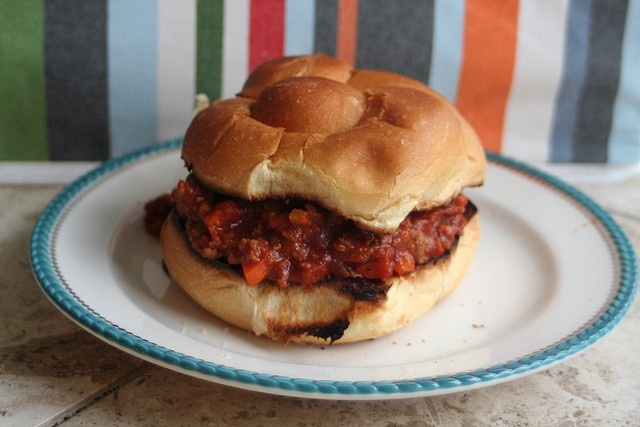Describe the objects in this image and their specific colors. I can see a sandwich in darkgreen, brown, maroon, black, and tan tones in this image. 